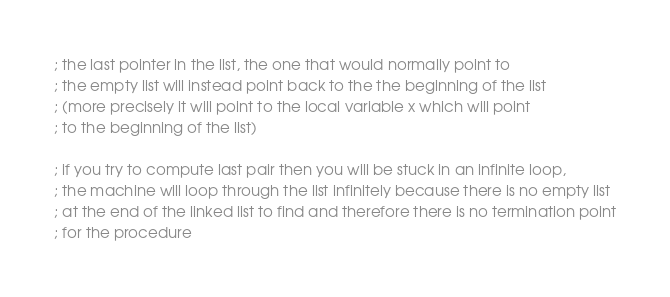<code> <loc_0><loc_0><loc_500><loc_500><_Scheme_>; the last pointer in the list, the one that would normally point to
; the empty list will instead point back to the the beginning of the list
; (more precisely it will point to the local variable x which will point
; to the beginning of the list)

; if you try to compute last pair then you will be stuck in an infinite loop,
; the machine will loop through the list infinitely because there is no empty list
; at the end of the linked list to find and therefore there is no termination point
; for the procedure
</code> 